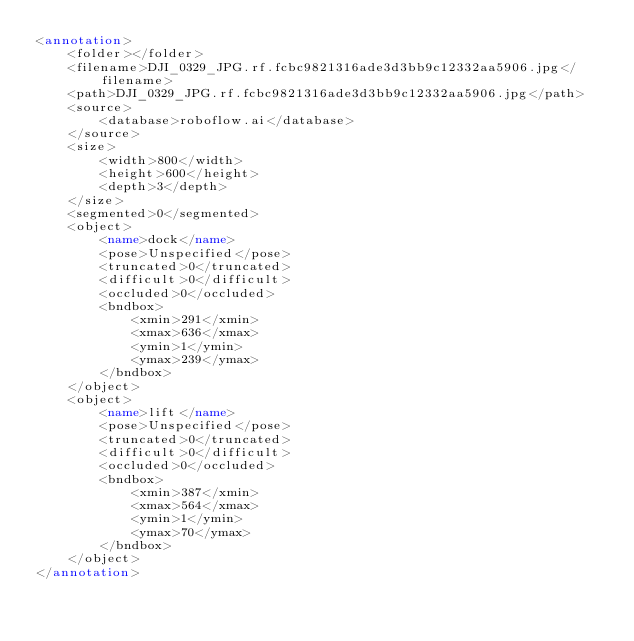<code> <loc_0><loc_0><loc_500><loc_500><_XML_><annotation>
	<folder></folder>
	<filename>DJI_0329_JPG.rf.fcbc9821316ade3d3bb9c12332aa5906.jpg</filename>
	<path>DJI_0329_JPG.rf.fcbc9821316ade3d3bb9c12332aa5906.jpg</path>
	<source>
		<database>roboflow.ai</database>
	</source>
	<size>
		<width>800</width>
		<height>600</height>
		<depth>3</depth>
	</size>
	<segmented>0</segmented>
	<object>
		<name>dock</name>
		<pose>Unspecified</pose>
		<truncated>0</truncated>
		<difficult>0</difficult>
		<occluded>0</occluded>
		<bndbox>
			<xmin>291</xmin>
			<xmax>636</xmax>
			<ymin>1</ymin>
			<ymax>239</ymax>
		</bndbox>
	</object>
	<object>
		<name>lift</name>
		<pose>Unspecified</pose>
		<truncated>0</truncated>
		<difficult>0</difficult>
		<occluded>0</occluded>
		<bndbox>
			<xmin>387</xmin>
			<xmax>564</xmax>
			<ymin>1</ymin>
			<ymax>70</ymax>
		</bndbox>
	</object>
</annotation>
</code> 